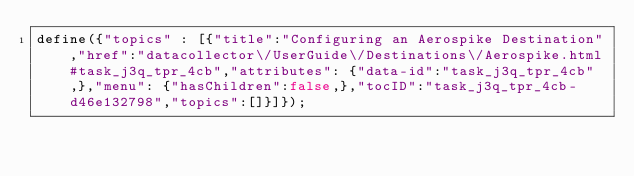Convert code to text. <code><loc_0><loc_0><loc_500><loc_500><_JavaScript_>define({"topics" : [{"title":"Configuring an Aerospike Destination","href":"datacollector\/UserGuide\/Destinations\/Aerospike.html#task_j3q_tpr_4cb","attributes": {"data-id":"task_j3q_tpr_4cb",},"menu": {"hasChildren":false,},"tocID":"task_j3q_tpr_4cb-d46e132798","topics":[]}]});</code> 